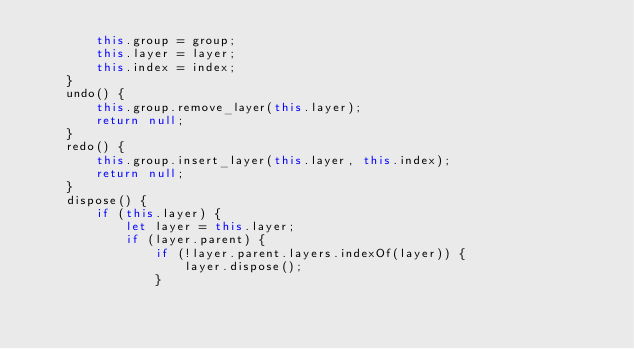<code> <loc_0><loc_0><loc_500><loc_500><_JavaScript_>        this.group = group;
        this.layer = layer;
        this.index = index;
    }
    undo() {
        this.group.remove_layer(this.layer);
        return null;
    }
    redo() {
        this.group.insert_layer(this.layer, this.index);
        return null;
    }
    dispose() {
        if (this.layer) {
            let layer = this.layer;
            if (layer.parent) {
                if (!layer.parent.layers.indexOf(layer)) {
                    layer.dispose();
                }</code> 